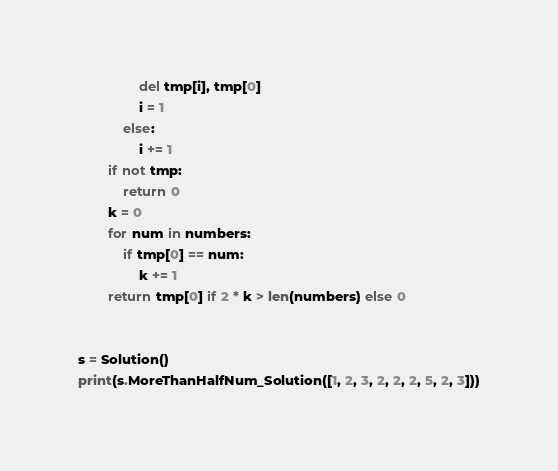Convert code to text. <code><loc_0><loc_0><loc_500><loc_500><_Python_>                del tmp[i], tmp[0]
                i = 1
            else:
                i += 1
        if not tmp:
            return 0
        k = 0
        for num in numbers:
            if tmp[0] == num:
                k += 1
        return tmp[0] if 2 * k > len(numbers) else 0


s = Solution()
print(s.MoreThanHalfNum_Solution([1, 2, 3, 2, 2, 2, 5, 2, 3]))
</code> 